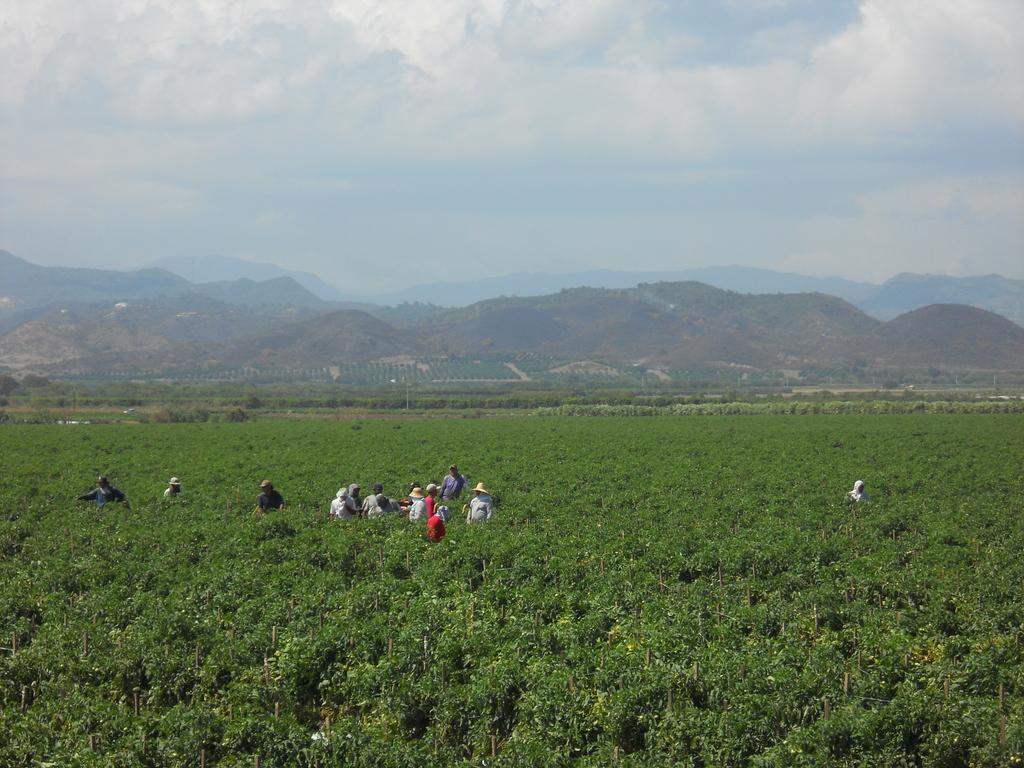What is the main subject of the image? The main subject of the image is people standing in a plantation field. What can be seen in the background of the image? In the background, there are hills with trees. What is visible in the sky in the image? The sky is visible with clouds. What is the name of the governor who is present in the image? There is no indication of a governor being present in the image. 